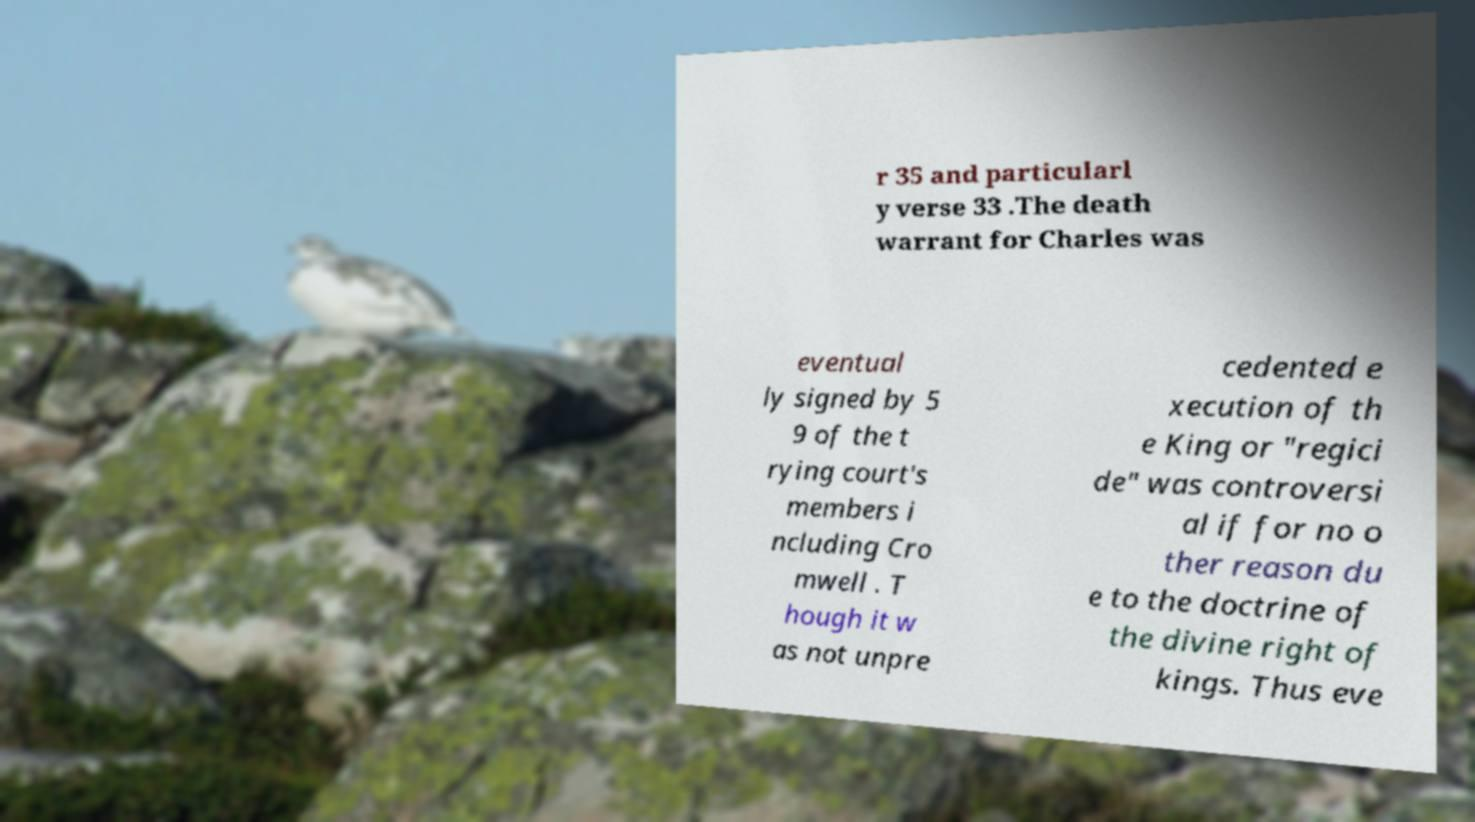Please identify and transcribe the text found in this image. r 35 and particularl y verse 33 .The death warrant for Charles was eventual ly signed by 5 9 of the t rying court's members i ncluding Cro mwell . T hough it w as not unpre cedented e xecution of th e King or "regici de" was controversi al if for no o ther reason du e to the doctrine of the divine right of kings. Thus eve 